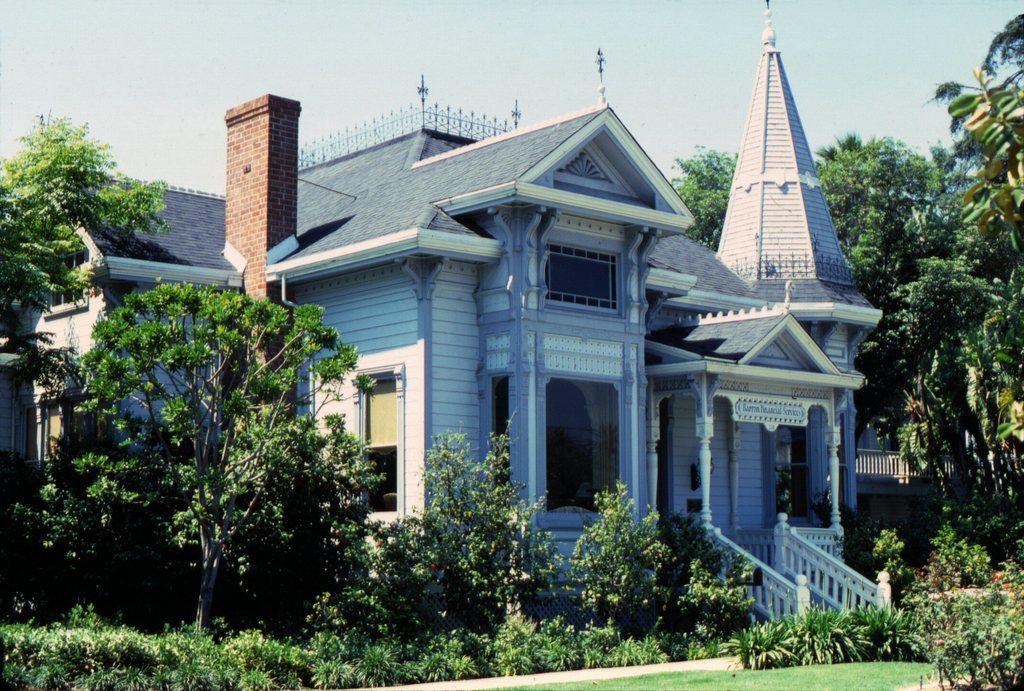Could you give a brief overview of what you see in this image? In this image I can see few trees, plants, grass, a house, windows and in the background I can see the sky. 